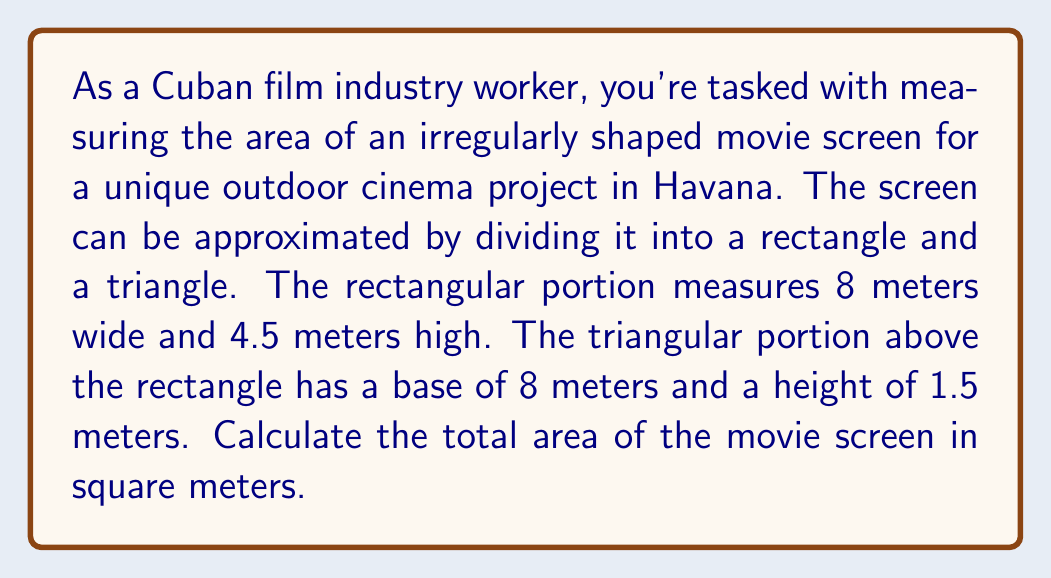Help me with this question. To solve this problem, we'll break it down into steps:

1. Calculate the area of the rectangular portion:
   $$A_{rectangle} = width \times height$$
   $$A_{rectangle} = 8 \text{ m} \times 4.5 \text{ m} = 36 \text{ m}^2$$

2. Calculate the area of the triangular portion:
   $$A_{triangle} = \frac{1}{2} \times base \times height$$
   $$A_{triangle} = \frac{1}{2} \times 8 \text{ m} \times 1.5 \text{ m} = 6 \text{ m}^2$$

3. Sum the areas to get the total area of the movie screen:
   $$A_{total} = A_{rectangle} + A_{triangle}$$
   $$A_{total} = 36 \text{ m}^2 + 6 \text{ m}^2 = 42 \text{ m}^2$$

[asy]
import geometry;

draw((0,0)--(8,0)--(8,4.5)--(0,4.5)--cycle);
draw((0,4.5)--(8,4.5)--(4,6)--cycle);
draw((4,6)--(4,4.5),dashed);

label("8 m", (4,0), S);
label("4.5 m", (0,2.25), W);
label("1.5 m", (4,5.25), E);

dot((0,0));
dot((8,0));
dot((8,4.5));
dot((0,4.5));
dot((4,6));
[/asy]
Answer: The total area of the irregularly shaped movie screen is 42 m². 